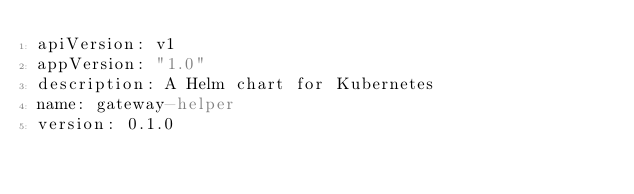Convert code to text. <code><loc_0><loc_0><loc_500><loc_500><_YAML_>apiVersion: v1
appVersion: "1.0"
description: A Helm chart for Kubernetes
name: gateway-helper
version: 0.1.0
</code> 